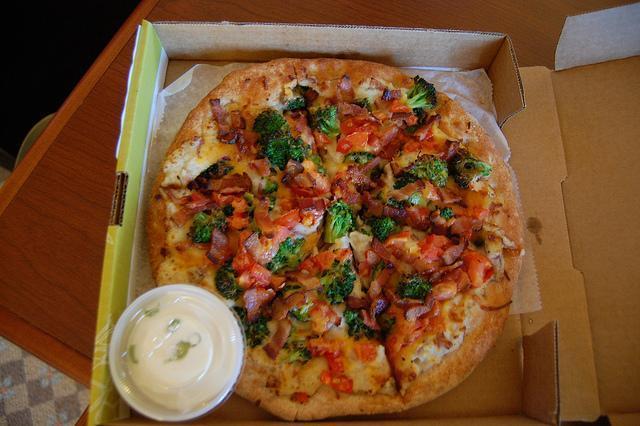How many slices have been taken on the pizza?
Give a very brief answer. 0. How many dining tables can be seen?
Give a very brief answer. 1. How many pizzas are there?
Give a very brief answer. 4. 